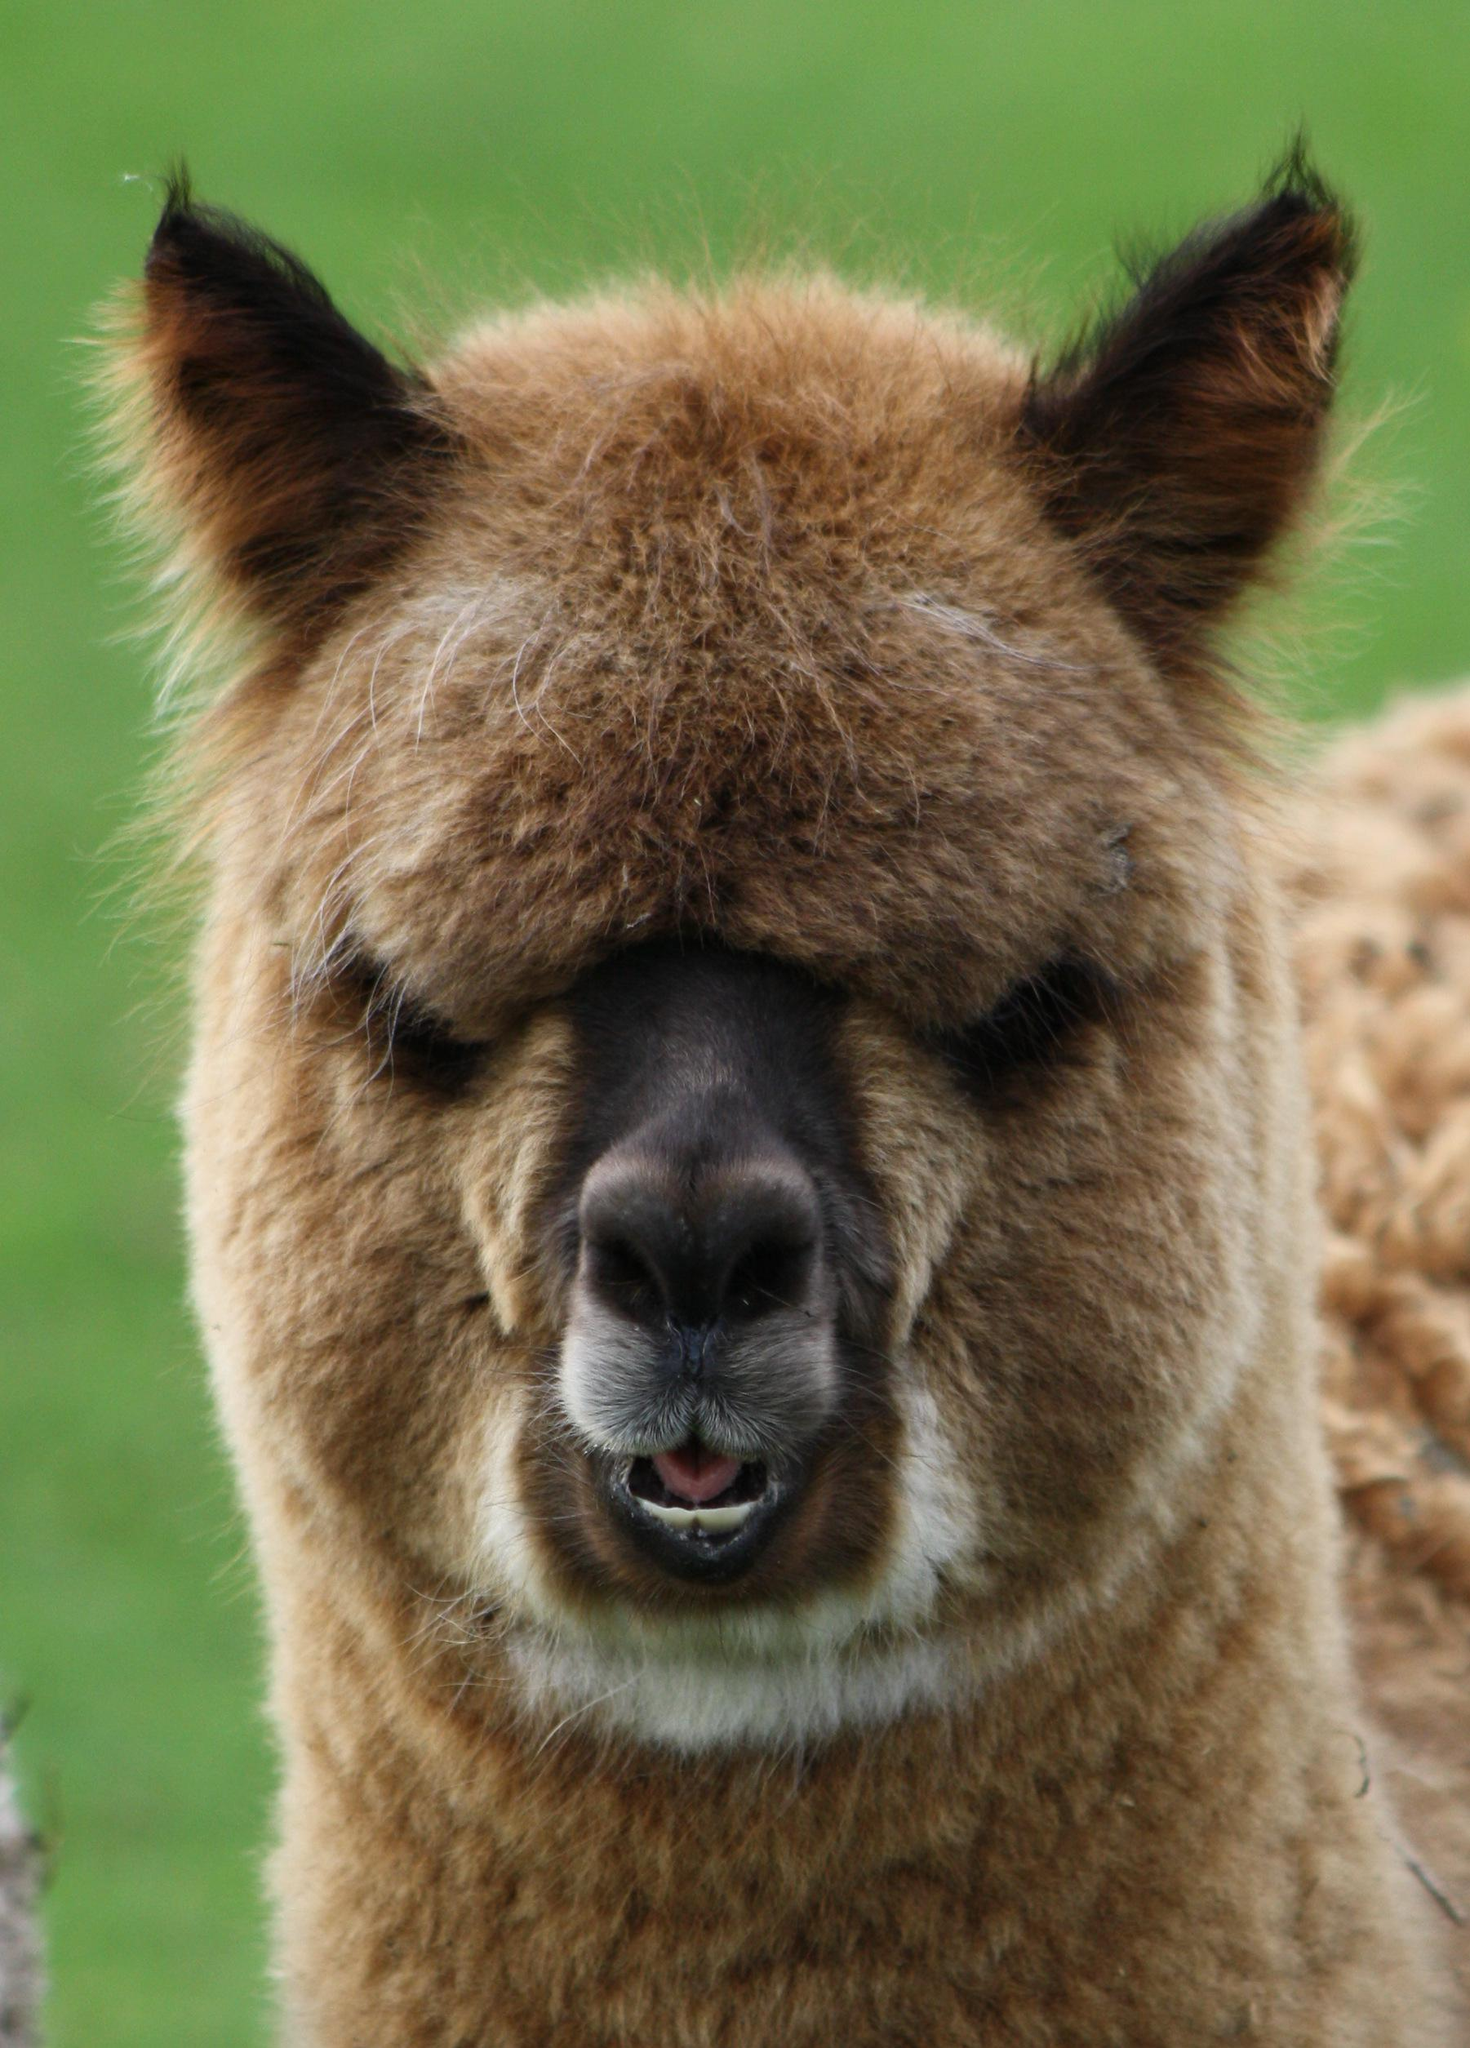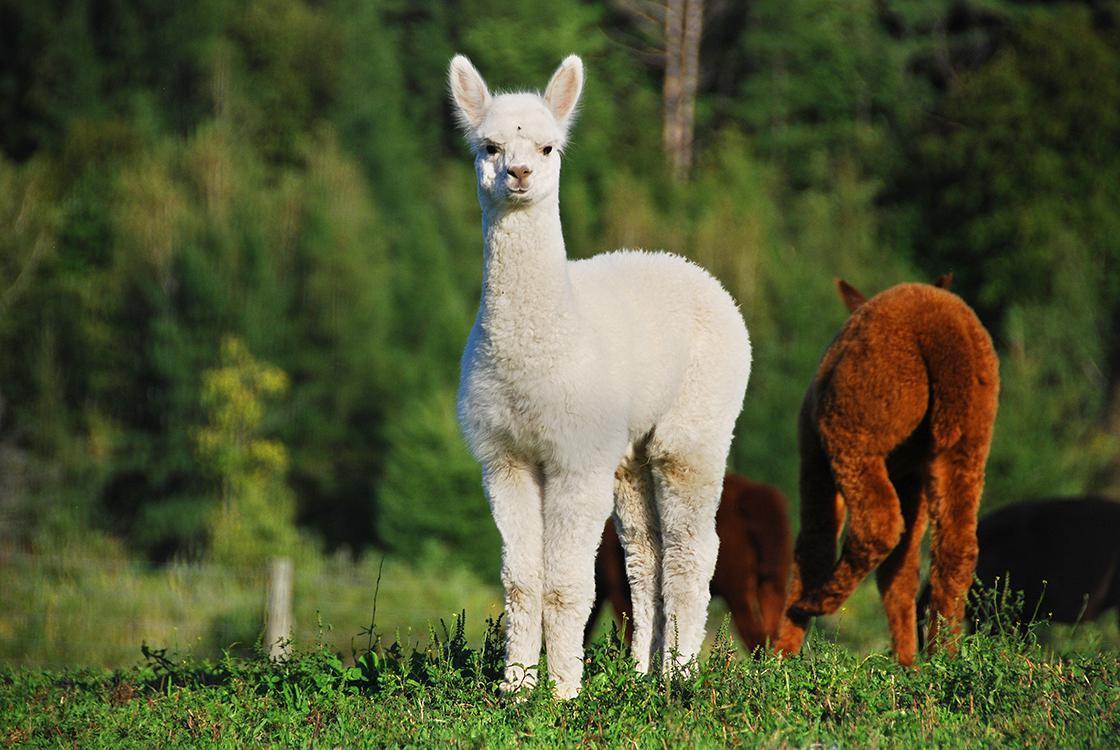The first image is the image on the left, the second image is the image on the right. Considering the images on both sides, is "The right image contains exactly three llamas with heads close together, one of them white, and the left image shows two heads close together, at least one belonging to a light-colored llama." valid? Answer yes or no. No. 